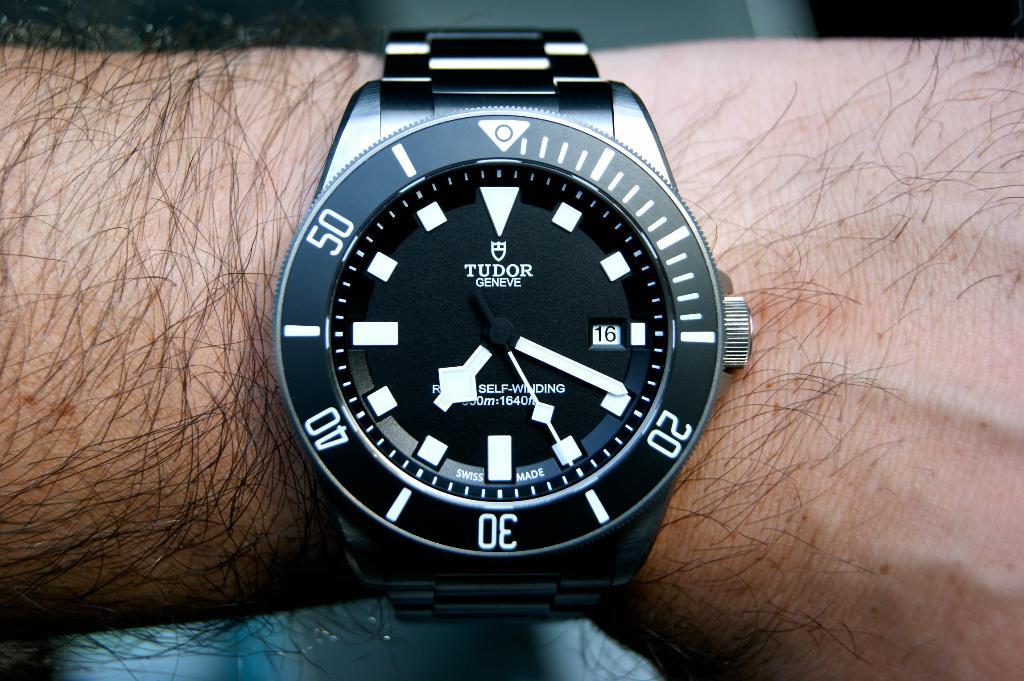What watch brand is the black watch?
Offer a terse response. Tudor. What time is the watch currently showing?
Your answer should be compact. 7:19. 